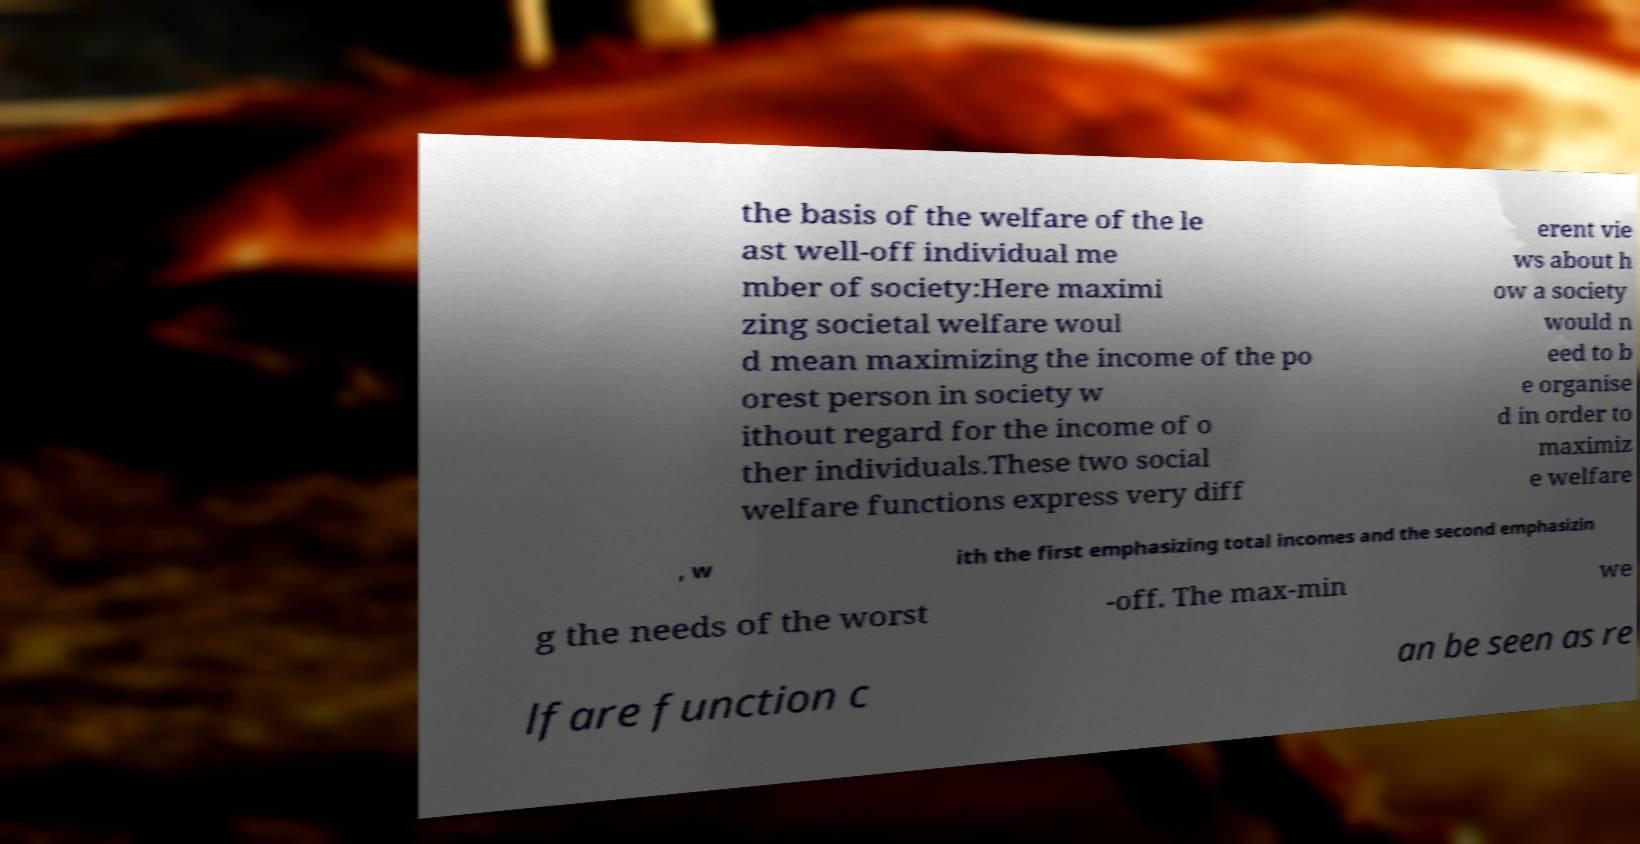Can you accurately transcribe the text from the provided image for me? the basis of the welfare of the le ast well-off individual me mber of society:Here maximi zing societal welfare woul d mean maximizing the income of the po orest person in society w ithout regard for the income of o ther individuals.These two social welfare functions express very diff erent vie ws about h ow a society would n eed to b e organise d in order to maximiz e welfare , w ith the first emphasizing total incomes and the second emphasizin g the needs of the worst -off. The max-min we lfare function c an be seen as re 